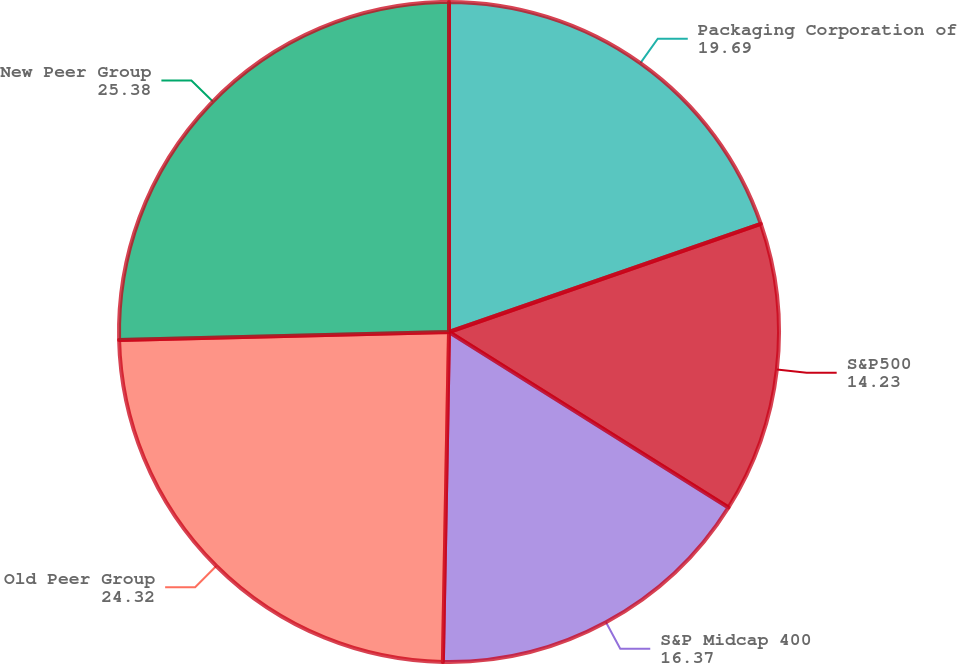Convert chart. <chart><loc_0><loc_0><loc_500><loc_500><pie_chart><fcel>Packaging Corporation of<fcel>S&P500<fcel>S&P Midcap 400<fcel>Old Peer Group<fcel>New Peer Group<nl><fcel>19.69%<fcel>14.23%<fcel>16.37%<fcel>24.32%<fcel>25.38%<nl></chart> 